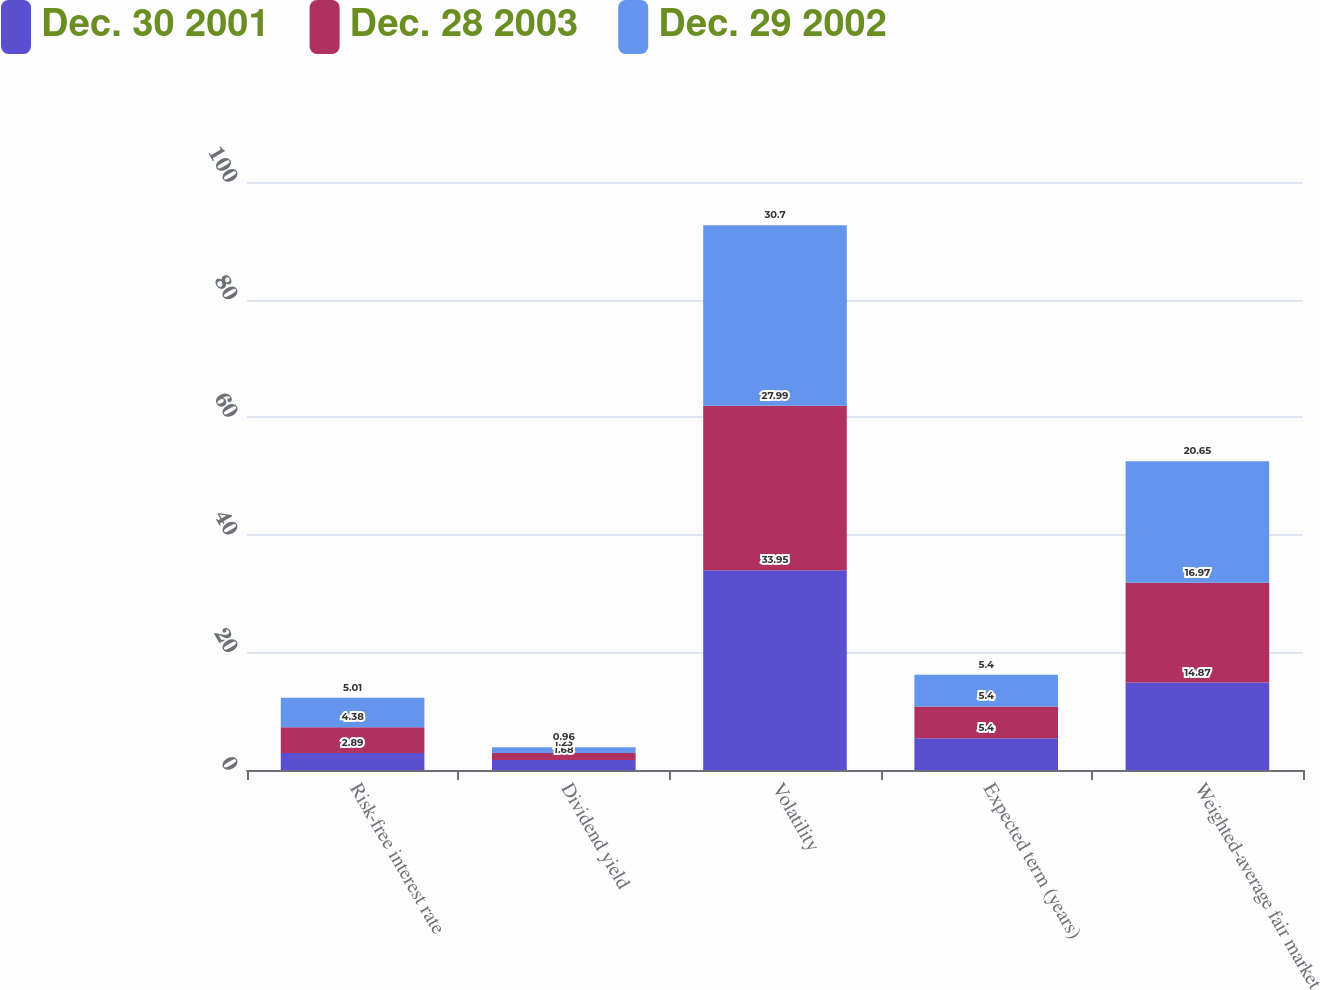<chart> <loc_0><loc_0><loc_500><loc_500><stacked_bar_chart><ecel><fcel>Risk-free interest rate<fcel>Dividend yield<fcel>Volatility<fcel>Expected term (years)<fcel>Weighted-average fair market<nl><fcel>Dec. 30 2001<fcel>2.89<fcel>1.68<fcel>33.95<fcel>5.4<fcel>14.87<nl><fcel>Dec. 28 2003<fcel>4.38<fcel>1.23<fcel>27.99<fcel>5.4<fcel>16.97<nl><fcel>Dec. 29 2002<fcel>5.01<fcel>0.96<fcel>30.7<fcel>5.4<fcel>20.65<nl></chart> 